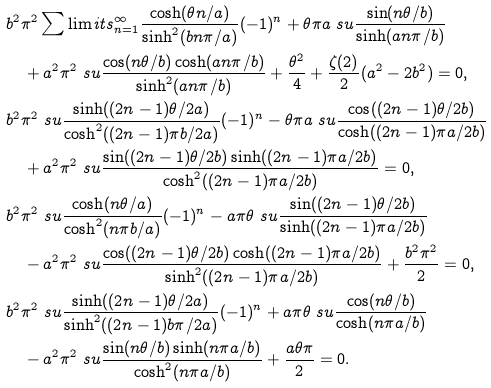Convert formula to latex. <formula><loc_0><loc_0><loc_500><loc_500>& b ^ { 2 } \pi ^ { 2 } \sum \lim i t s _ { n = 1 } ^ { \infty } \frac { \cosh ( \theta n / a ) } { \sinh ^ { 2 } ( b n \pi / a ) } ( - 1 ) ^ { n } + \theta \pi a \ s u \frac { \sin ( n \theta / b ) } { \sinh ( a n \pi / b ) } \\ & \quad + a ^ { 2 } \pi ^ { 2 } \ s u \frac { \cos ( n \theta / b ) \cosh ( a n \pi / b ) } { \sinh ^ { 2 } ( a n \pi / b ) } + \frac { \theta ^ { 2 } } { 4 } + \frac { \zeta ( 2 ) } { 2 } ( a ^ { 2 } - 2 b ^ { 2 } ) = 0 , \\ & b ^ { 2 } \pi ^ { 2 } \ s u \frac { \sinh ( ( 2 n - 1 ) \theta / 2 a ) } { \cosh ^ { 2 } ( ( 2 n - 1 ) \pi b / 2 a ) } ( - 1 ) ^ { n } - \theta \pi a \ s u \frac { \cos ( ( 2 n - 1 ) \theta / 2 b ) } { \cosh ( ( 2 n - 1 ) \pi a / 2 b ) } \\ & \quad + a ^ { 2 } \pi ^ { 2 } \ s u \frac { \sin ( ( 2 n - 1 ) \theta / 2 b ) \sinh ( ( 2 n - 1 ) \pi a / 2 b ) } { \cosh ^ { 2 } ( ( 2 n - 1 ) \pi a / 2 b ) } = 0 , \\ & b ^ { 2 } \pi ^ { 2 } \ s u \frac { \cosh ( n \theta / a ) } { \cosh ^ { 2 } ( n \pi b / a ) } ( - 1 ) ^ { n } - a \pi \theta \ s u \frac { \sin ( ( 2 n - 1 ) \theta / 2 b ) } { \sinh ( ( 2 n - 1 ) \pi a / 2 b ) } \\ & \quad - a ^ { 2 } \pi ^ { 2 } \ s u \frac { \cos ( ( 2 n - 1 ) \theta / 2 b ) \cosh ( ( 2 n - 1 ) \pi a / 2 b ) } { \sinh ^ { 2 } ( ( 2 n - 1 ) \pi a / 2 b ) } + \frac { b ^ { 2 } \pi ^ { 2 } } { 2 } = 0 , \\ & b ^ { 2 } \pi ^ { 2 } \ s u \frac { \sinh ( ( 2 n - 1 ) \theta / 2 a ) } { \sinh ^ { 2 } ( ( 2 n - 1 ) b \pi / 2 a ) } ( - 1 ) ^ { n } + a \pi \theta \ s u \frac { \cos ( n \theta / b ) } { \cosh ( n \pi a / b ) } \\ & \quad - a ^ { 2 } \pi ^ { 2 } \ s u \frac { \sin ( n \theta / b ) \sinh ( n \pi a / b ) } { \cosh ^ { 2 } ( n \pi a / b ) } + \frac { a \theta \pi } { 2 } = 0 .</formula> 